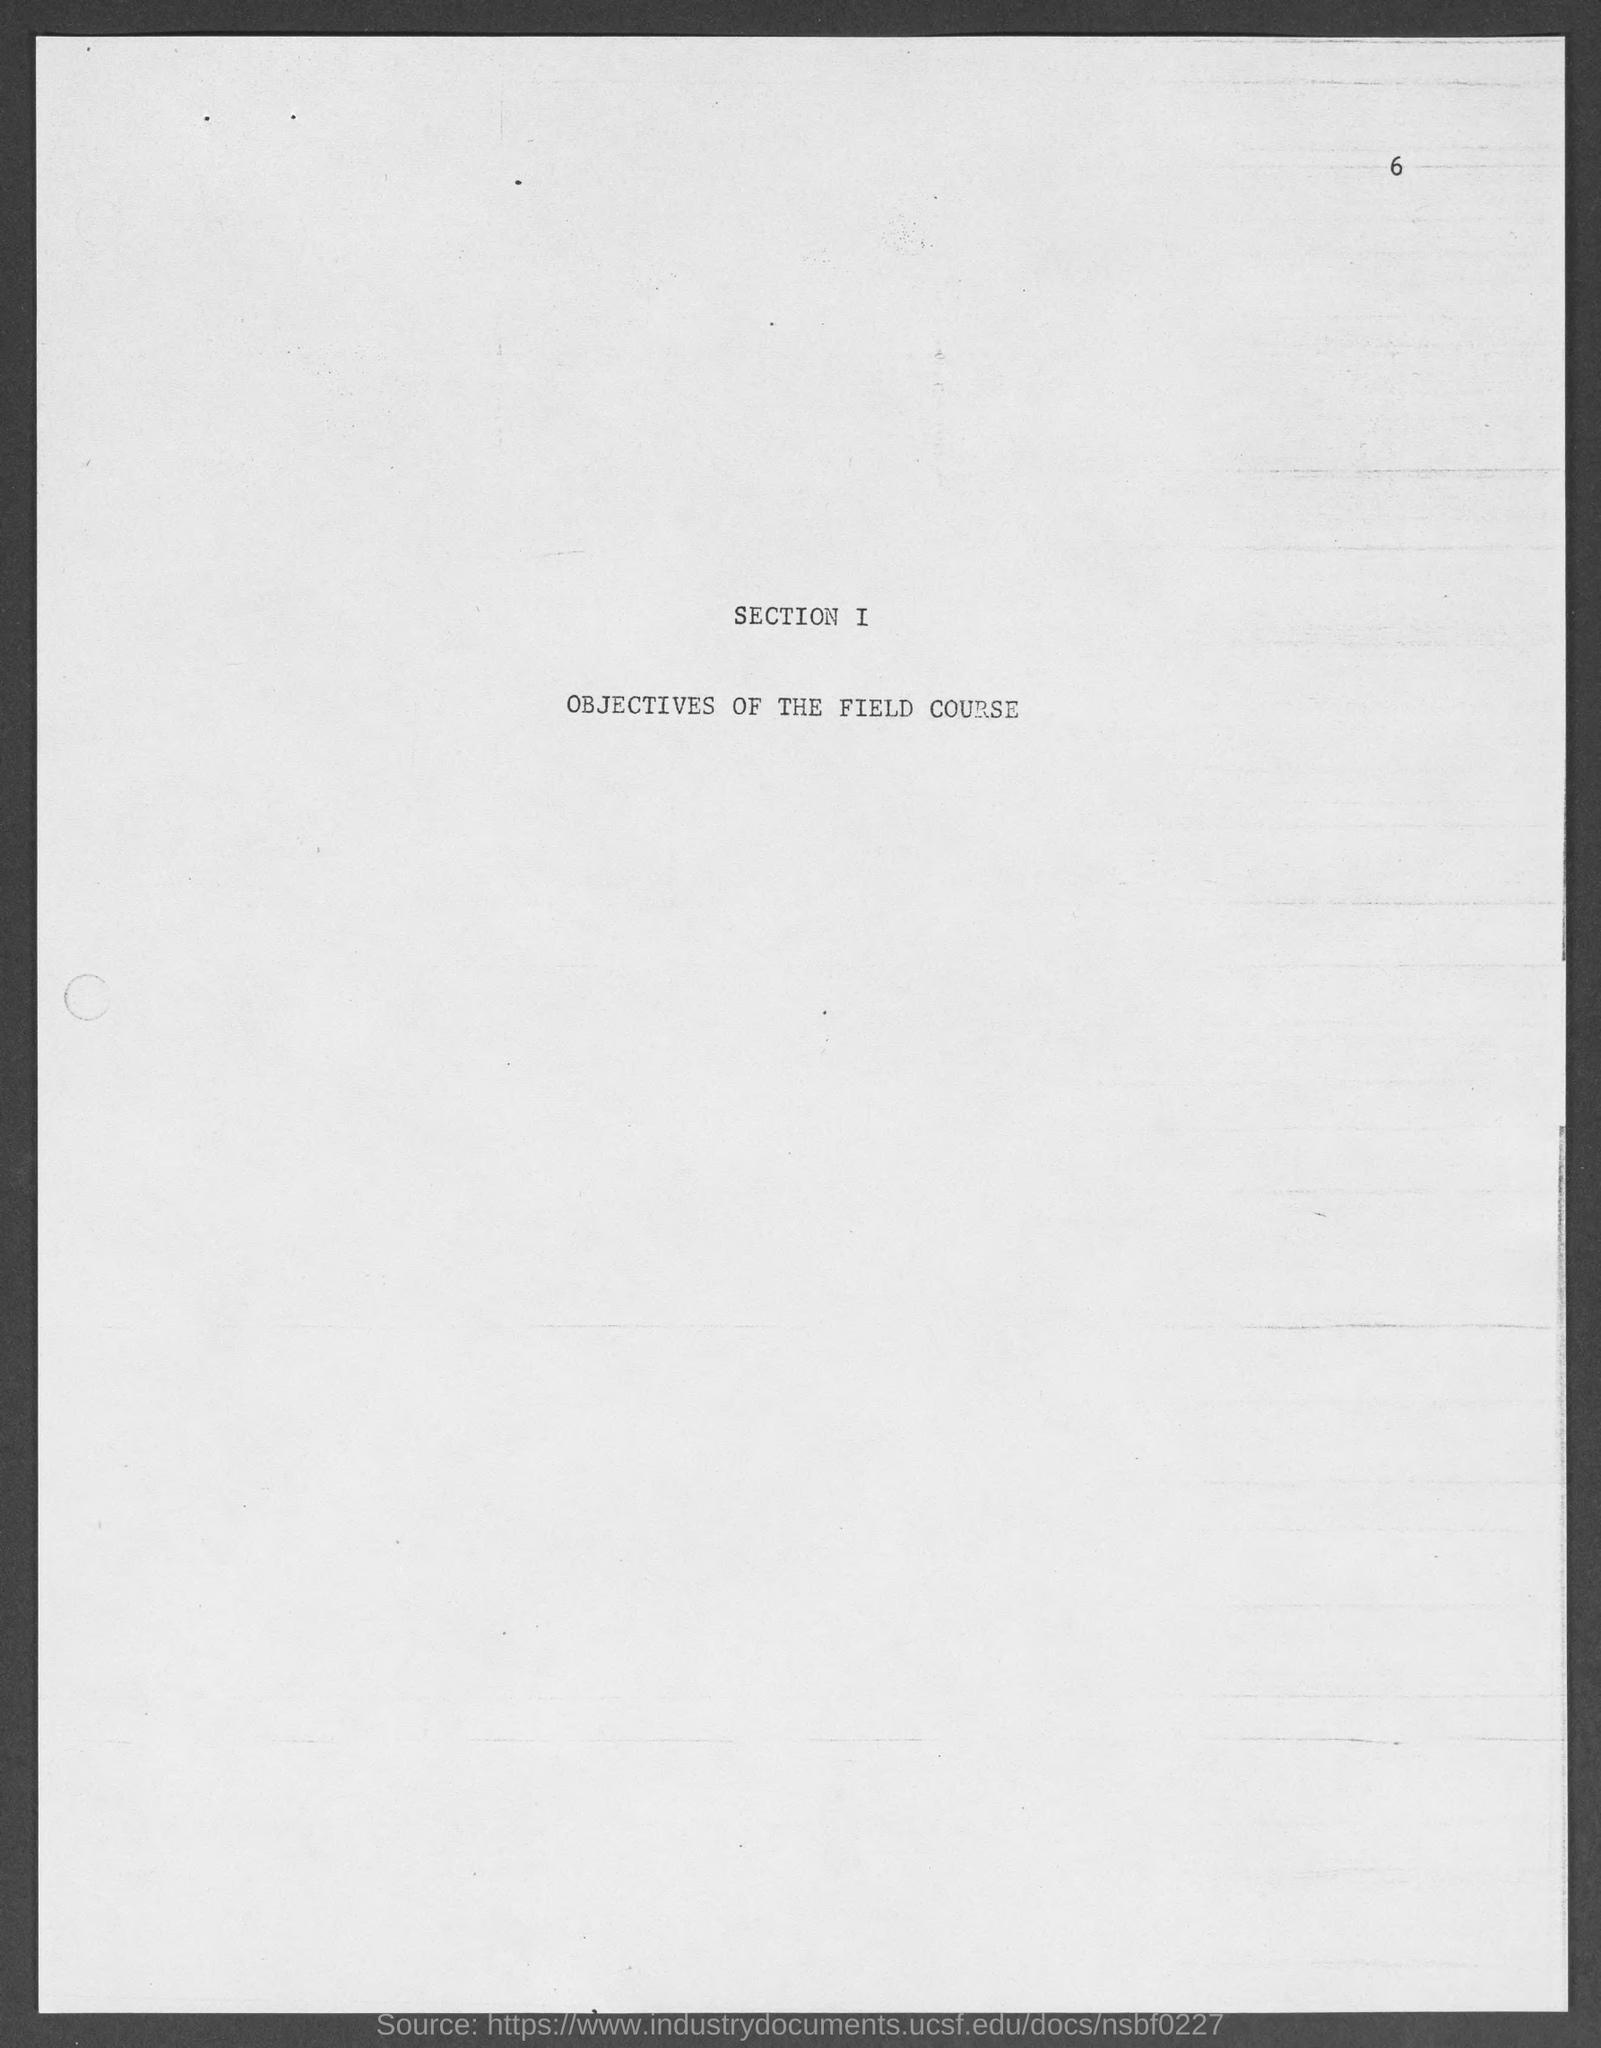Specify some key components in this picture. The objectives of the field course belong to Section I of the course. The page number at the top of the page is 6. 